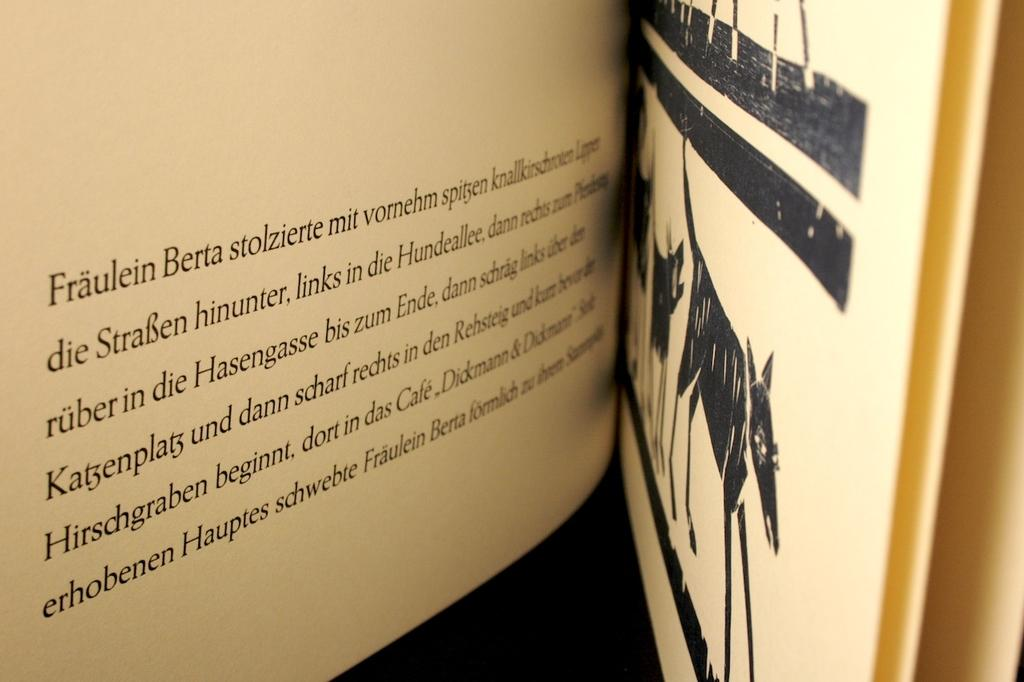Provide a one-sentence caption for the provided image. The text beginning with "Fraulein Berta" on the left and an illustration of a cow on the right side of the page. 